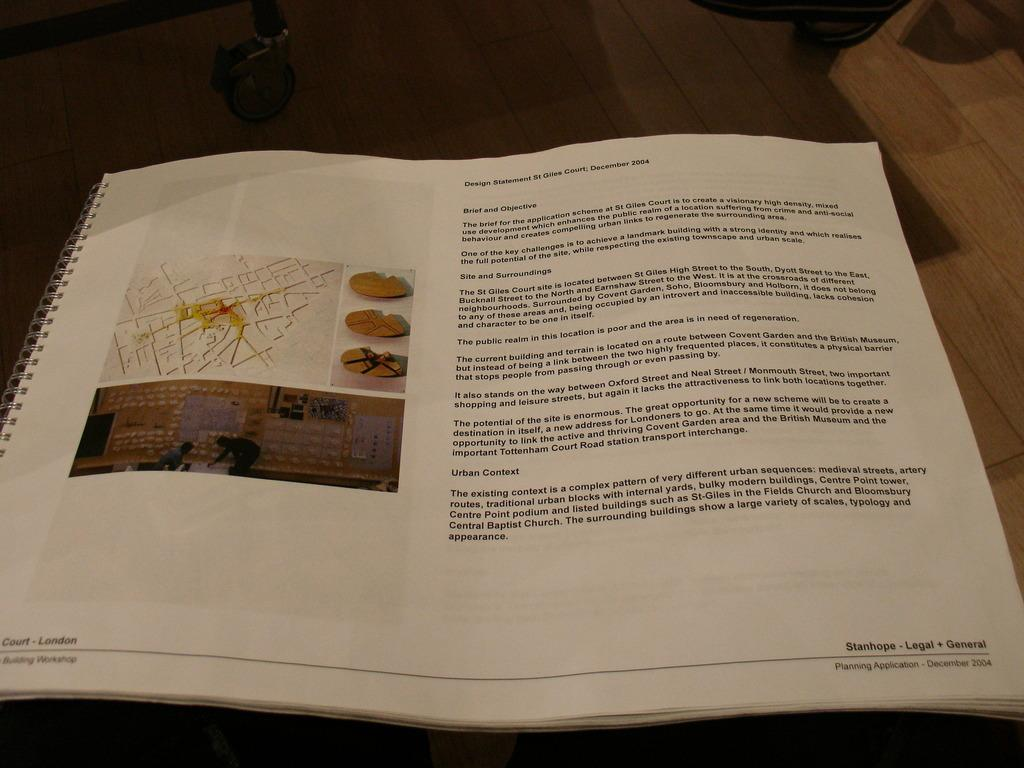<image>
Offer a succinct explanation of the picture presented. A book is open to a page that says Brief and Objective. 